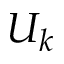Convert formula to latex. <formula><loc_0><loc_0><loc_500><loc_500>U _ { k }</formula> 